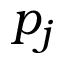<formula> <loc_0><loc_0><loc_500><loc_500>p _ { j }</formula> 